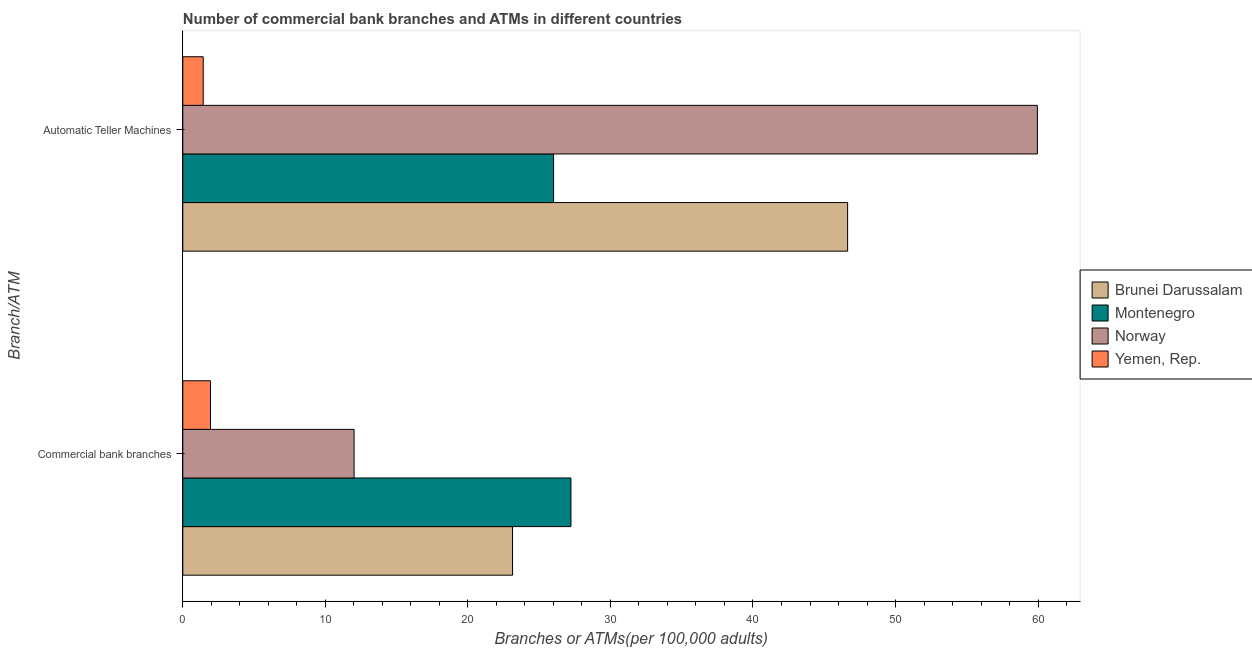How many different coloured bars are there?
Provide a short and direct response. 4. How many bars are there on the 2nd tick from the top?
Give a very brief answer. 4. How many bars are there on the 2nd tick from the bottom?
Provide a short and direct response. 4. What is the label of the 1st group of bars from the top?
Give a very brief answer. Automatic Teller Machines. What is the number of commercal bank branches in Montenegro?
Provide a succinct answer. 27.23. Across all countries, what is the maximum number of atms?
Your answer should be very brief. 59.95. Across all countries, what is the minimum number of atms?
Offer a terse response. 1.43. In which country was the number of commercal bank branches maximum?
Provide a succinct answer. Montenegro. In which country was the number of commercal bank branches minimum?
Make the answer very short. Yemen, Rep. What is the total number of atms in the graph?
Your answer should be compact. 134.03. What is the difference between the number of atms in Brunei Darussalam and that in Yemen, Rep.?
Your answer should be very brief. 45.21. What is the difference between the number of atms in Brunei Darussalam and the number of commercal bank branches in Montenegro?
Offer a very short reply. 19.41. What is the average number of commercal bank branches per country?
Make the answer very short. 16.08. What is the difference between the number of commercal bank branches and number of atms in Montenegro?
Provide a succinct answer. 1.22. What is the ratio of the number of atms in Brunei Darussalam to that in Norway?
Keep it short and to the point. 0.78. Is the number of atms in Montenegro less than that in Brunei Darussalam?
Your answer should be compact. Yes. What does the 3rd bar from the top in Automatic Teller Machines represents?
Your answer should be very brief. Montenegro. How many countries are there in the graph?
Offer a terse response. 4. Are the values on the major ticks of X-axis written in scientific E-notation?
Keep it short and to the point. No. Does the graph contain any zero values?
Keep it short and to the point. No. How many legend labels are there?
Your response must be concise. 4. How are the legend labels stacked?
Give a very brief answer. Vertical. What is the title of the graph?
Your response must be concise. Number of commercial bank branches and ATMs in different countries. What is the label or title of the X-axis?
Keep it short and to the point. Branches or ATMs(per 100,0 adults). What is the label or title of the Y-axis?
Offer a very short reply. Branch/ATM. What is the Branches or ATMs(per 100,000 adults) of Brunei Darussalam in Commercial bank branches?
Your answer should be compact. 23.13. What is the Branches or ATMs(per 100,000 adults) in Montenegro in Commercial bank branches?
Keep it short and to the point. 27.23. What is the Branches or ATMs(per 100,000 adults) in Norway in Commercial bank branches?
Your answer should be compact. 12.02. What is the Branches or ATMs(per 100,000 adults) of Yemen, Rep. in Commercial bank branches?
Offer a very short reply. 1.94. What is the Branches or ATMs(per 100,000 adults) of Brunei Darussalam in Automatic Teller Machines?
Offer a terse response. 46.64. What is the Branches or ATMs(per 100,000 adults) of Montenegro in Automatic Teller Machines?
Provide a succinct answer. 26.01. What is the Branches or ATMs(per 100,000 adults) of Norway in Automatic Teller Machines?
Provide a succinct answer. 59.95. What is the Branches or ATMs(per 100,000 adults) in Yemen, Rep. in Automatic Teller Machines?
Make the answer very short. 1.43. Across all Branch/ATM, what is the maximum Branches or ATMs(per 100,000 adults) of Brunei Darussalam?
Your answer should be very brief. 46.64. Across all Branch/ATM, what is the maximum Branches or ATMs(per 100,000 adults) of Montenegro?
Provide a succinct answer. 27.23. Across all Branch/ATM, what is the maximum Branches or ATMs(per 100,000 adults) in Norway?
Offer a terse response. 59.95. Across all Branch/ATM, what is the maximum Branches or ATMs(per 100,000 adults) of Yemen, Rep.?
Offer a terse response. 1.94. Across all Branch/ATM, what is the minimum Branches or ATMs(per 100,000 adults) in Brunei Darussalam?
Keep it short and to the point. 23.13. Across all Branch/ATM, what is the minimum Branches or ATMs(per 100,000 adults) of Montenegro?
Keep it short and to the point. 26.01. Across all Branch/ATM, what is the minimum Branches or ATMs(per 100,000 adults) in Norway?
Make the answer very short. 12.02. Across all Branch/ATM, what is the minimum Branches or ATMs(per 100,000 adults) in Yemen, Rep.?
Your response must be concise. 1.43. What is the total Branches or ATMs(per 100,000 adults) in Brunei Darussalam in the graph?
Provide a succinct answer. 69.77. What is the total Branches or ATMs(per 100,000 adults) of Montenegro in the graph?
Make the answer very short. 53.24. What is the total Branches or ATMs(per 100,000 adults) in Norway in the graph?
Keep it short and to the point. 71.97. What is the total Branches or ATMs(per 100,000 adults) of Yemen, Rep. in the graph?
Keep it short and to the point. 3.38. What is the difference between the Branches or ATMs(per 100,000 adults) in Brunei Darussalam in Commercial bank branches and that in Automatic Teller Machines?
Ensure brevity in your answer.  -23.51. What is the difference between the Branches or ATMs(per 100,000 adults) in Montenegro in Commercial bank branches and that in Automatic Teller Machines?
Make the answer very short. 1.22. What is the difference between the Branches or ATMs(per 100,000 adults) in Norway in Commercial bank branches and that in Automatic Teller Machines?
Your answer should be compact. -47.93. What is the difference between the Branches or ATMs(per 100,000 adults) in Yemen, Rep. in Commercial bank branches and that in Automatic Teller Machines?
Keep it short and to the point. 0.51. What is the difference between the Branches or ATMs(per 100,000 adults) of Brunei Darussalam in Commercial bank branches and the Branches or ATMs(per 100,000 adults) of Montenegro in Automatic Teller Machines?
Give a very brief answer. -2.88. What is the difference between the Branches or ATMs(per 100,000 adults) in Brunei Darussalam in Commercial bank branches and the Branches or ATMs(per 100,000 adults) in Norway in Automatic Teller Machines?
Your response must be concise. -36.82. What is the difference between the Branches or ATMs(per 100,000 adults) of Brunei Darussalam in Commercial bank branches and the Branches or ATMs(per 100,000 adults) of Yemen, Rep. in Automatic Teller Machines?
Keep it short and to the point. 21.7. What is the difference between the Branches or ATMs(per 100,000 adults) in Montenegro in Commercial bank branches and the Branches or ATMs(per 100,000 adults) in Norway in Automatic Teller Machines?
Give a very brief answer. -32.72. What is the difference between the Branches or ATMs(per 100,000 adults) of Montenegro in Commercial bank branches and the Branches or ATMs(per 100,000 adults) of Yemen, Rep. in Automatic Teller Machines?
Ensure brevity in your answer.  25.8. What is the difference between the Branches or ATMs(per 100,000 adults) of Norway in Commercial bank branches and the Branches or ATMs(per 100,000 adults) of Yemen, Rep. in Automatic Teller Machines?
Keep it short and to the point. 10.58. What is the average Branches or ATMs(per 100,000 adults) of Brunei Darussalam per Branch/ATM?
Your answer should be compact. 34.89. What is the average Branches or ATMs(per 100,000 adults) in Montenegro per Branch/ATM?
Provide a succinct answer. 26.62. What is the average Branches or ATMs(per 100,000 adults) in Norway per Branch/ATM?
Keep it short and to the point. 35.98. What is the average Branches or ATMs(per 100,000 adults) of Yemen, Rep. per Branch/ATM?
Provide a succinct answer. 1.69. What is the difference between the Branches or ATMs(per 100,000 adults) in Brunei Darussalam and Branches or ATMs(per 100,000 adults) in Montenegro in Commercial bank branches?
Your answer should be compact. -4.1. What is the difference between the Branches or ATMs(per 100,000 adults) of Brunei Darussalam and Branches or ATMs(per 100,000 adults) of Norway in Commercial bank branches?
Give a very brief answer. 11.12. What is the difference between the Branches or ATMs(per 100,000 adults) of Brunei Darussalam and Branches or ATMs(per 100,000 adults) of Yemen, Rep. in Commercial bank branches?
Your response must be concise. 21.19. What is the difference between the Branches or ATMs(per 100,000 adults) in Montenegro and Branches or ATMs(per 100,000 adults) in Norway in Commercial bank branches?
Ensure brevity in your answer.  15.21. What is the difference between the Branches or ATMs(per 100,000 adults) in Montenegro and Branches or ATMs(per 100,000 adults) in Yemen, Rep. in Commercial bank branches?
Give a very brief answer. 25.29. What is the difference between the Branches or ATMs(per 100,000 adults) in Norway and Branches or ATMs(per 100,000 adults) in Yemen, Rep. in Commercial bank branches?
Offer a very short reply. 10.07. What is the difference between the Branches or ATMs(per 100,000 adults) in Brunei Darussalam and Branches or ATMs(per 100,000 adults) in Montenegro in Automatic Teller Machines?
Your answer should be very brief. 20.63. What is the difference between the Branches or ATMs(per 100,000 adults) in Brunei Darussalam and Branches or ATMs(per 100,000 adults) in Norway in Automatic Teller Machines?
Your answer should be compact. -13.31. What is the difference between the Branches or ATMs(per 100,000 adults) in Brunei Darussalam and Branches or ATMs(per 100,000 adults) in Yemen, Rep. in Automatic Teller Machines?
Provide a succinct answer. 45.21. What is the difference between the Branches or ATMs(per 100,000 adults) in Montenegro and Branches or ATMs(per 100,000 adults) in Norway in Automatic Teller Machines?
Your response must be concise. -33.94. What is the difference between the Branches or ATMs(per 100,000 adults) in Montenegro and Branches or ATMs(per 100,000 adults) in Yemen, Rep. in Automatic Teller Machines?
Your answer should be very brief. 24.58. What is the difference between the Branches or ATMs(per 100,000 adults) in Norway and Branches or ATMs(per 100,000 adults) in Yemen, Rep. in Automatic Teller Machines?
Keep it short and to the point. 58.52. What is the ratio of the Branches or ATMs(per 100,000 adults) in Brunei Darussalam in Commercial bank branches to that in Automatic Teller Machines?
Give a very brief answer. 0.5. What is the ratio of the Branches or ATMs(per 100,000 adults) in Montenegro in Commercial bank branches to that in Automatic Teller Machines?
Your response must be concise. 1.05. What is the ratio of the Branches or ATMs(per 100,000 adults) in Norway in Commercial bank branches to that in Automatic Teller Machines?
Give a very brief answer. 0.2. What is the ratio of the Branches or ATMs(per 100,000 adults) in Yemen, Rep. in Commercial bank branches to that in Automatic Teller Machines?
Provide a succinct answer. 1.36. What is the difference between the highest and the second highest Branches or ATMs(per 100,000 adults) in Brunei Darussalam?
Provide a short and direct response. 23.51. What is the difference between the highest and the second highest Branches or ATMs(per 100,000 adults) in Montenegro?
Offer a very short reply. 1.22. What is the difference between the highest and the second highest Branches or ATMs(per 100,000 adults) of Norway?
Make the answer very short. 47.93. What is the difference between the highest and the second highest Branches or ATMs(per 100,000 adults) in Yemen, Rep.?
Make the answer very short. 0.51. What is the difference between the highest and the lowest Branches or ATMs(per 100,000 adults) of Brunei Darussalam?
Provide a succinct answer. 23.51. What is the difference between the highest and the lowest Branches or ATMs(per 100,000 adults) in Montenegro?
Ensure brevity in your answer.  1.22. What is the difference between the highest and the lowest Branches or ATMs(per 100,000 adults) in Norway?
Give a very brief answer. 47.93. What is the difference between the highest and the lowest Branches or ATMs(per 100,000 adults) in Yemen, Rep.?
Your answer should be very brief. 0.51. 